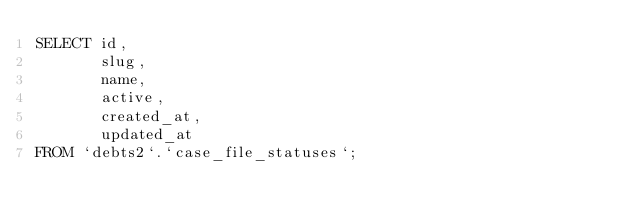<code> <loc_0><loc_0><loc_500><loc_500><_SQL_>SELECT id, 
       slug, 
       name, 
       active, 
       created_at, 
       updated_at
FROM `debts2`.`case_file_statuses`;</code> 